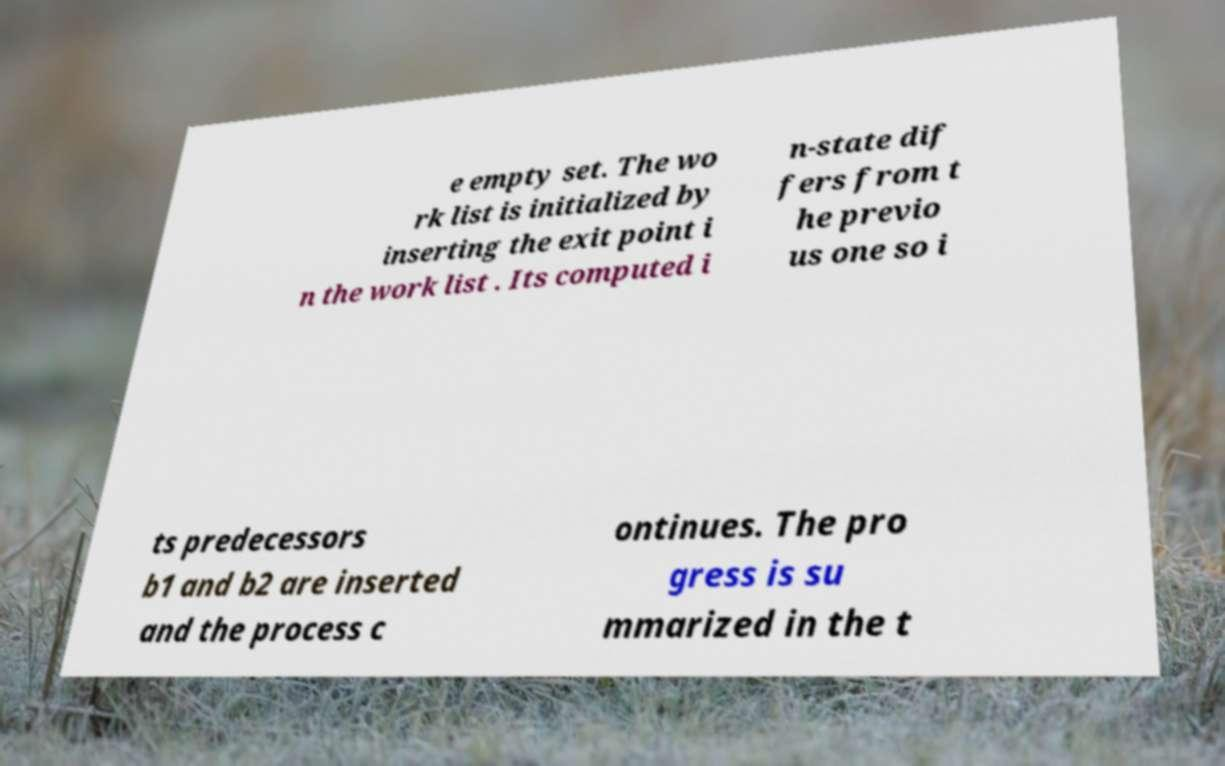Can you accurately transcribe the text from the provided image for me? e empty set. The wo rk list is initialized by inserting the exit point i n the work list . Its computed i n-state dif fers from t he previo us one so i ts predecessors b1 and b2 are inserted and the process c ontinues. The pro gress is su mmarized in the t 